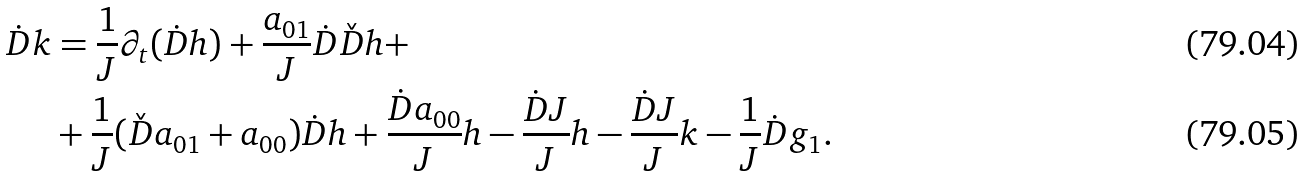<formula> <loc_0><loc_0><loc_500><loc_500>\dot { D } k & = \frac { 1 } { J } \partial _ { t } ( \dot { D } h ) + \frac { a _ { 0 1 } } { J } \dot { D } \check { D } h + \\ & + \frac { 1 } { J } ( \check { D } a _ { 0 1 } + a _ { 0 0 } ) \dot { D } h + \frac { \dot { D } a _ { 0 0 } } { J } h - \frac { \dot { D } J } { J } h - \frac { \dot { D } J } { J } k - \frac { 1 } { J } \dot { D } g _ { 1 } .</formula> 